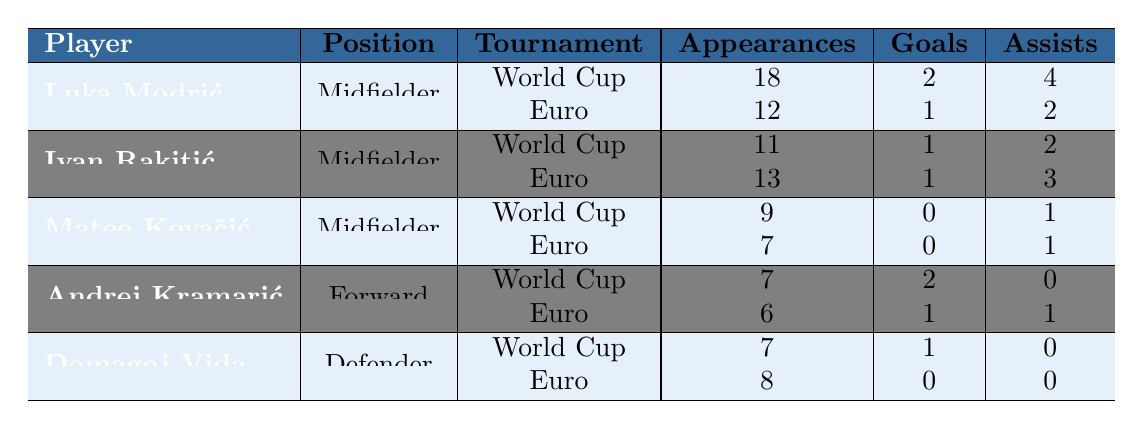What is the total number of appearances made by Luka Modrić in international tournaments? Luka Modrić played in the FIFA World Cup for a total of 18 appearances and in the UEFA European Championship for 12 appearances. Therefore, the total is 18 + 12 = 30.
Answer: 30 How many goals did Ivan Rakitić score in total across all tournaments? Ivan Rakitić scored 1 goal in the FIFA World Cup and 1 goal in the UEFA European Championship. Thus, the total is 1 + 1 = 2.
Answer: 2 Which player had the highest number of assists in the FIFA World Cup? Luka Modrić had 4 assists in the FIFA World Cup, which is the highest when compared to the other players' assists listed in that tournament.
Answer: Luka Modrić Did Mateo Kovačić score any goals in the UEFA European Championship? Mateo Kovačić played in the UEFA European Championship and recorded 0 goals according to the table. Therefore, the answer is no.
Answer: No What is the average number of appearances made by the players listed in the table for the UEFA European Championship? The total appearances in the UEFA European Championship are 12 (Modrić) + 13 (Rakitić) + 7 (Kovačić) + 6 (Kramarić) + 8 (Vida) = 46. There are 5 players, so the average is 46/5 = 9.2.
Answer: 9.2 Which player had the least number of goals in the FIFA World Cup from 2010 to 2022? Mateo Kovačić did not score any goals in the FIFA World Cup, which is less than any other player's goals listed for that tournament.
Answer: Mateo Kovačić Who had more total assists across both tournaments, Luka Modrić or Andrej Kramarić? Luka Modrić has 4 assists in the World Cup and 2 in the Euro, totaling 6 assists. Andrej Kramarić has 0 assists in the World Cup and 1 in the Euro, totaling 1 assist. Therefore, Modrić has more total assists.
Answer: Luka Modrić How many goals did the average midfielder score in all tournaments? The midfielders Luka Modrić, Ivan Rakitić, and Mateo Kovačić scored a total of 2 (Modrić) + 1 (Rakitić) + 0 (Kovačić) = 3 goals. There are 3 midfielders, so the average is 3/3 = 1.
Answer: 1 Which tournament had the most total goals scored by Croatian players? In the FIFA World Cup, Croatian players scored a total of 2 (Modrić) + 1 (Rakitić) + 2 (Kramarić) + 1 (Vida) = 6 goals. In the UEFA European Championship, they scored 1 (Modrić) + 1 (Rakitić) + 0 (Kovačić) + 1 (Kramarić) + 0 (Vida) = 3 goals. Thus, the FIFA World Cup had more total goals.
Answer: FIFA World Cup What percentage of Luka Modrić's assists came in the FIFA World Cup? Luka Modrić had 4 assists in the FIFA World Cup and a total of 6 assists across both tournaments. Therefore, the percentage from the World Cup is (4/6) * 100 = 66.67%.
Answer: 66.67% 